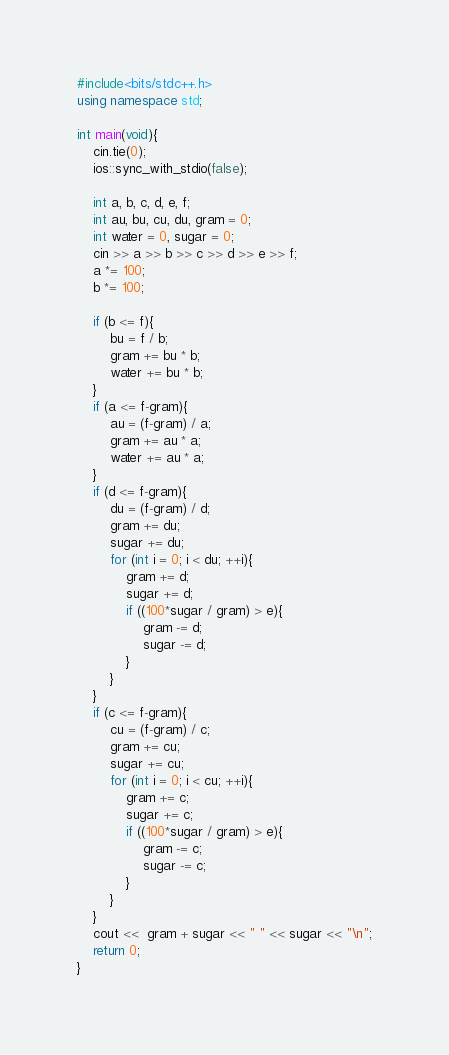<code> <loc_0><loc_0><loc_500><loc_500><_C++_>#include<bits/stdc++.h>
using namespace std;

int main(void){
	cin.tie(0);
	ios::sync_with_stdio(false);

	int a, b, c, d, e, f;
	int au, bu, cu, du, gram = 0;
	int water = 0, sugar = 0;
	cin >> a >> b >> c >> d >> e >> f;
	a *= 100;
	b *= 100;

	if (b <= f){
		bu = f / b;
		gram += bu * b;
		water += bu * b;
	}
	if (a <= f-gram){
		au = (f-gram) / a;
		gram += au * a;
		water += au * a;
	}
	if (d <= f-gram){
		du = (f-gram) / d;
		gram += du;
		sugar += du;
		for (int i = 0; i < du; ++i){
			gram += d;
			sugar += d;
			if ((100*sugar / gram) > e){
				gram -= d;
				sugar -= d;
			}
		}
	}
	if (c <= f-gram){
		cu = (f-gram) / c;
		gram += cu;
		sugar += cu;
		for (int i = 0; i < cu; ++i){
			gram += c;
			sugar += c;
			if ((100*sugar / gram) > e){
				gram -= c;
				sugar -= c;
			}
		}
	}
	cout <<  gram + sugar << " " << sugar << "\n";
	return 0;
}</code> 